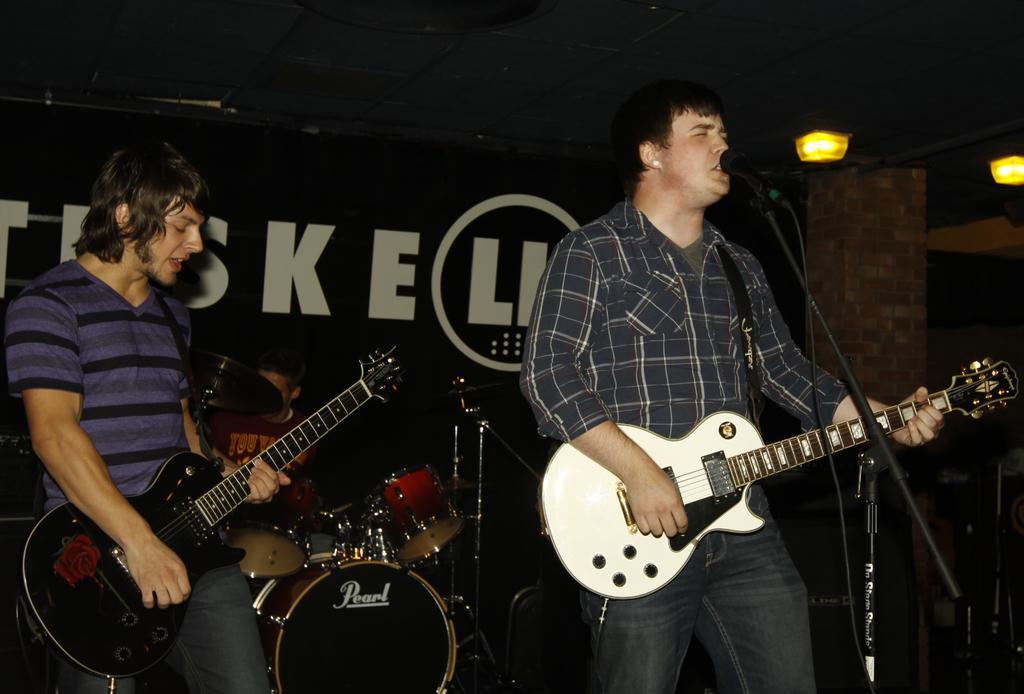Please provide a concise description of this image. In this image we can see there are two people standing and playing guitar, in front of them there is a mic, behind them there is another person playing a musical instrument. In the background there is a banner with some text and at the top of the image there are two lights. 